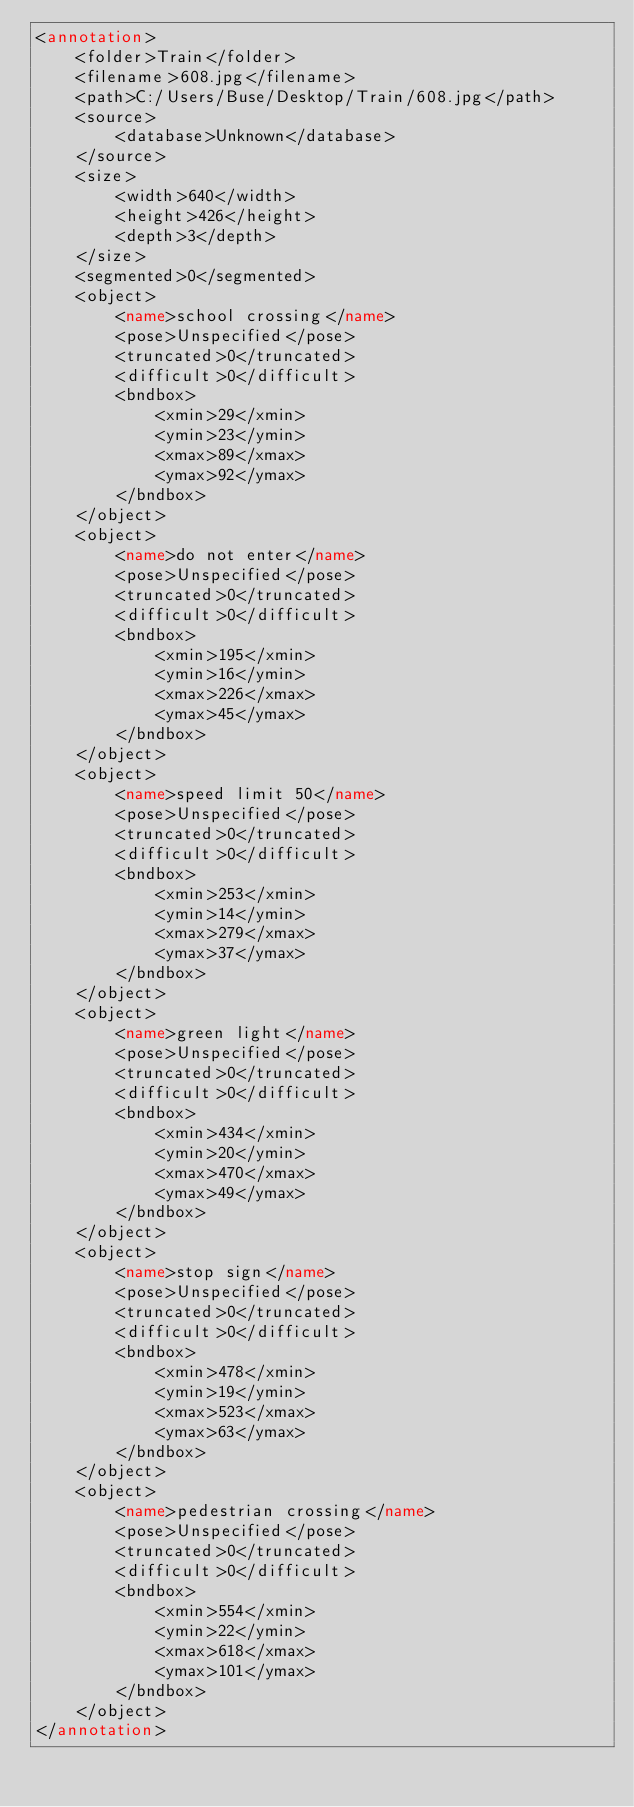Convert code to text. <code><loc_0><loc_0><loc_500><loc_500><_XML_><annotation>
	<folder>Train</folder>
	<filename>608.jpg</filename>
	<path>C:/Users/Buse/Desktop/Train/608.jpg</path>
	<source>
		<database>Unknown</database>
	</source>
	<size>
		<width>640</width>
		<height>426</height>
		<depth>3</depth>
	</size>
	<segmented>0</segmented>
	<object>
		<name>school crossing</name>
		<pose>Unspecified</pose>
		<truncated>0</truncated>
		<difficult>0</difficult>
		<bndbox>
			<xmin>29</xmin>
			<ymin>23</ymin>
			<xmax>89</xmax>
			<ymax>92</ymax>
		</bndbox>
	</object>
	<object>
		<name>do not enter</name>
		<pose>Unspecified</pose>
		<truncated>0</truncated>
		<difficult>0</difficult>
		<bndbox>
			<xmin>195</xmin>
			<ymin>16</ymin>
			<xmax>226</xmax>
			<ymax>45</ymax>
		</bndbox>
	</object>
	<object>
		<name>speed limit 50</name>
		<pose>Unspecified</pose>
		<truncated>0</truncated>
		<difficult>0</difficult>
		<bndbox>
			<xmin>253</xmin>
			<ymin>14</ymin>
			<xmax>279</xmax>
			<ymax>37</ymax>
		</bndbox>
	</object>
	<object>
		<name>green light</name>
		<pose>Unspecified</pose>
		<truncated>0</truncated>
		<difficult>0</difficult>
		<bndbox>
			<xmin>434</xmin>
			<ymin>20</ymin>
			<xmax>470</xmax>
			<ymax>49</ymax>
		</bndbox>
	</object>
	<object>
		<name>stop sign</name>
		<pose>Unspecified</pose>
		<truncated>0</truncated>
		<difficult>0</difficult>
		<bndbox>
			<xmin>478</xmin>
			<ymin>19</ymin>
			<xmax>523</xmax>
			<ymax>63</ymax>
		</bndbox>
	</object>
	<object>
		<name>pedestrian crossing</name>
		<pose>Unspecified</pose>
		<truncated>0</truncated>
		<difficult>0</difficult>
		<bndbox>
			<xmin>554</xmin>
			<ymin>22</ymin>
			<xmax>618</xmax>
			<ymax>101</ymax>
		</bndbox>
	</object>
</annotation>
</code> 